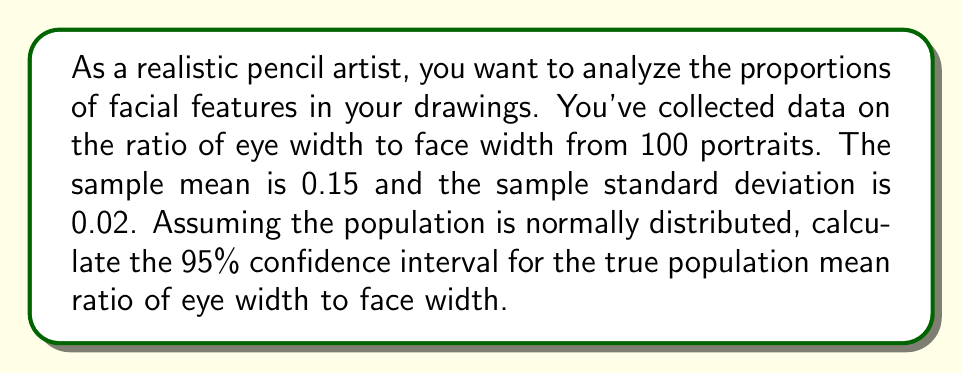Can you answer this question? To calculate the confidence interval, we'll use the formula:

$$ \text{CI} = \bar{x} \pm t_{\alpha/2, n-1} \cdot \frac{s}{\sqrt{n}} $$

Where:
- $\bar{x}$ is the sample mean (0.15)
- $s$ is the sample standard deviation (0.02)
- $n$ is the sample size (100)
- $t_{\alpha/2, n-1}$ is the t-value for a 95% confidence interval with 99 degrees of freedom

Steps:
1) For a 95% CI, $\alpha = 0.05$, so we need $t_{0.025, 99}$
2) From a t-table or calculator, we find $t_{0.025, 99} \approx 1.984$
3) Calculate the margin of error:
   $$ \text{ME} = t_{0.025, 99} \cdot \frac{s}{\sqrt{n}} = 1.984 \cdot \frac{0.02}{\sqrt{100}} \approx 0.003968 $$
4) Calculate the confidence interval:
   $$ \text{CI} = 0.15 \pm 0.003968 $$
   $$ \text{CI} = [0.146032, 0.153968] $$
Answer: The 95% confidence interval for the true population mean ratio of eye width to face width is [0.146, 0.154] (rounded to three decimal places). 